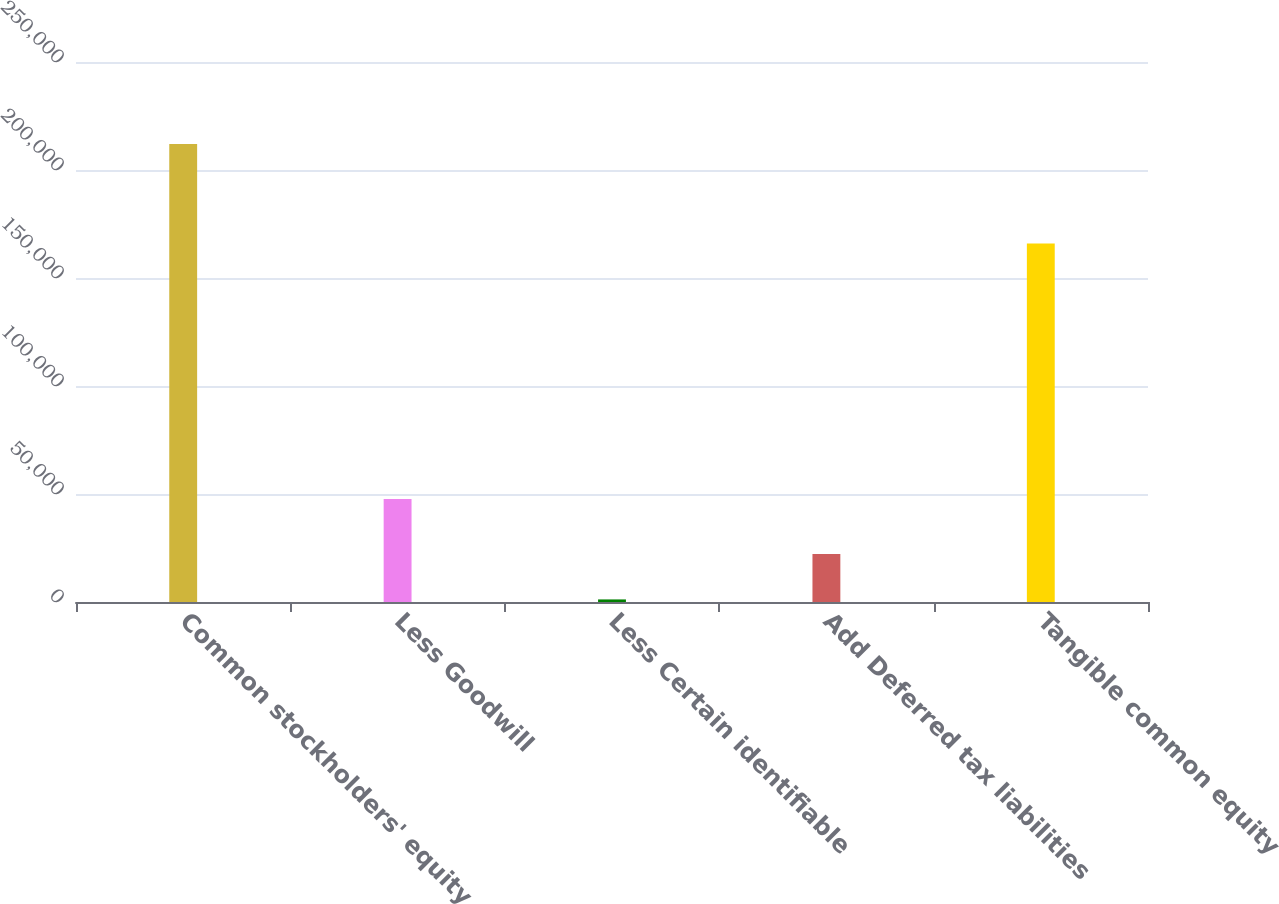Convert chart to OTSL. <chart><loc_0><loc_0><loc_500><loc_500><bar_chart><fcel>Common stockholders' equity<fcel>Less Goodwill<fcel>Less Certain identifiable<fcel>Add Deferred tax liabilities<fcel>Tangible common equity<nl><fcel>212002<fcel>47647<fcel>1192<fcel>22273<fcel>166016<nl></chart> 